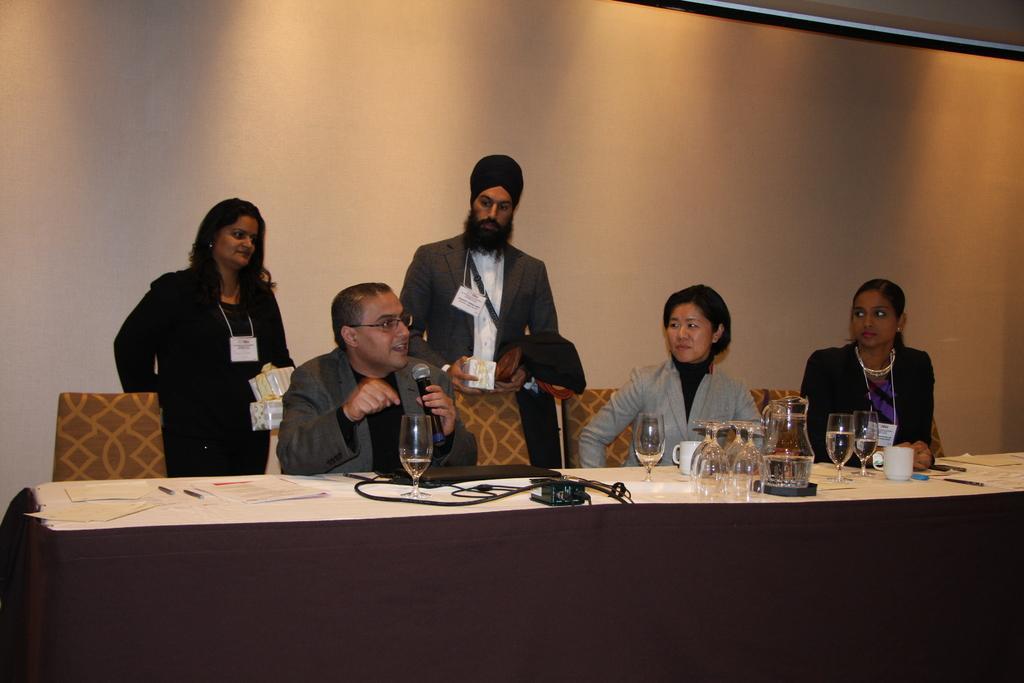How would you summarize this image in a sentence or two? The image is inside the room. In the image there are three people sitting on chair in front of a table on table we can see some papers,pen,glass,wires in background there are two people standing and also a wall which is in cream color. 